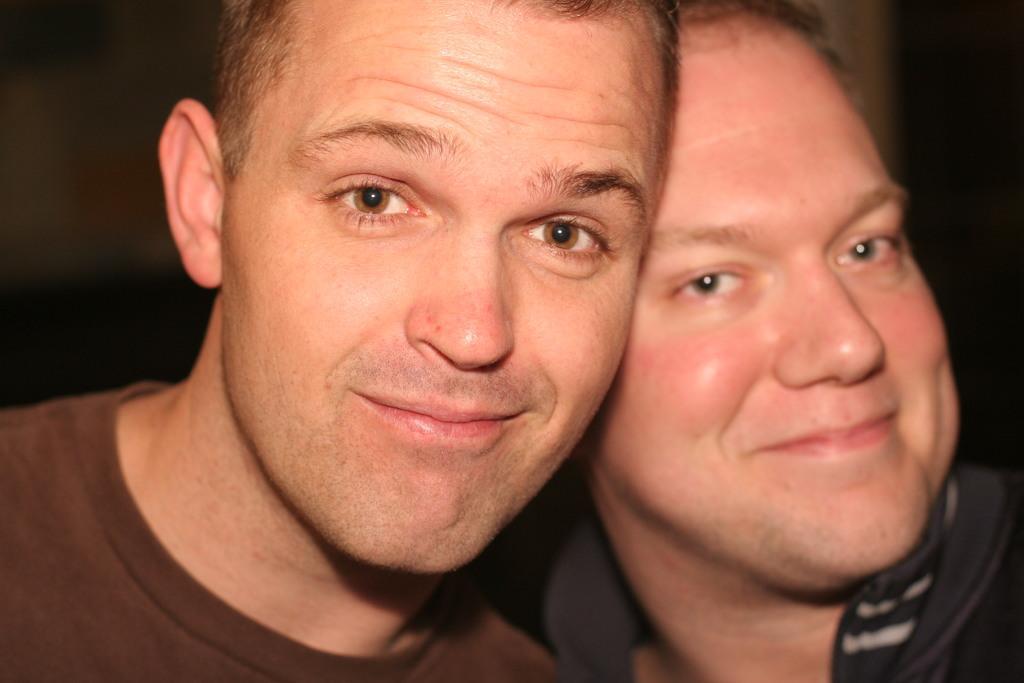In one or two sentences, can you explain what this image depicts? In this picture we can see two men smiling and in the background it is blurry. 